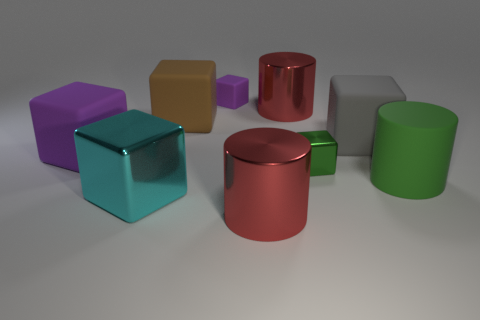What is the shape of the big purple thing that is the same material as the big green thing?
Provide a succinct answer. Cube. What shape is the purple rubber object that is the same size as the brown matte cube?
Offer a terse response. Cube. There is a large cylinder that is the same material as the brown thing; what is its color?
Ensure brevity in your answer.  Green. There is another object that is the same color as the small shiny object; what is its material?
Your answer should be very brief. Rubber. What number of things are small red metallic blocks or small metallic blocks?
Your response must be concise. 1. Are there any large cubes of the same color as the small matte block?
Make the answer very short. Yes. How many brown objects are right of the red metal cylinder that is behind the tiny metallic object?
Your answer should be very brief. 0. Is the number of tiny blue rubber spheres greater than the number of small metal cubes?
Offer a very short reply. No. Do the large cyan cube and the large brown thing have the same material?
Offer a terse response. No. Are there an equal number of purple rubber objects that are in front of the large purple rubber cube and cyan metallic things?
Provide a short and direct response. No. 